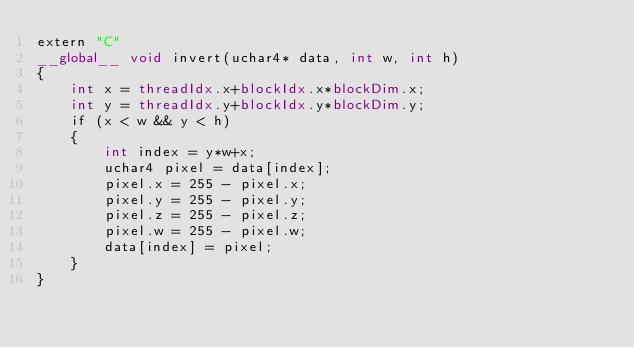<code> <loc_0><loc_0><loc_500><loc_500><_Cuda_>extern "C"
__global__ void invert(uchar4* data, int w, int h)
{
    int x = threadIdx.x+blockIdx.x*blockDim.x;
    int y = threadIdx.y+blockIdx.y*blockDim.y;
    if (x < w && y < h)
    {
        int index = y*w+x;
        uchar4 pixel = data[index];
        pixel.x = 255 - pixel.x;
        pixel.y = 255 - pixel.y;
        pixel.z = 255 - pixel.z;
        pixel.w = 255 - pixel.w;
        data[index] = pixel;
    }
}
</code> 